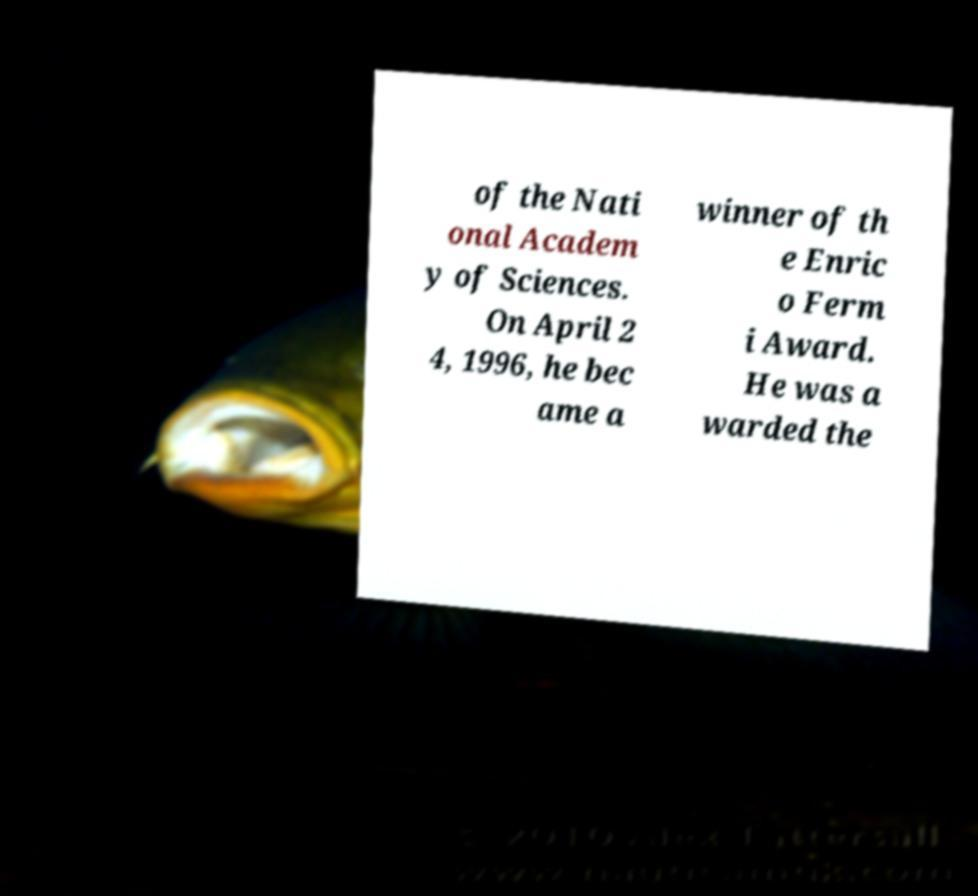I need the written content from this picture converted into text. Can you do that? of the Nati onal Academ y of Sciences. On April 2 4, 1996, he bec ame a winner of th e Enric o Ferm i Award. He was a warded the 